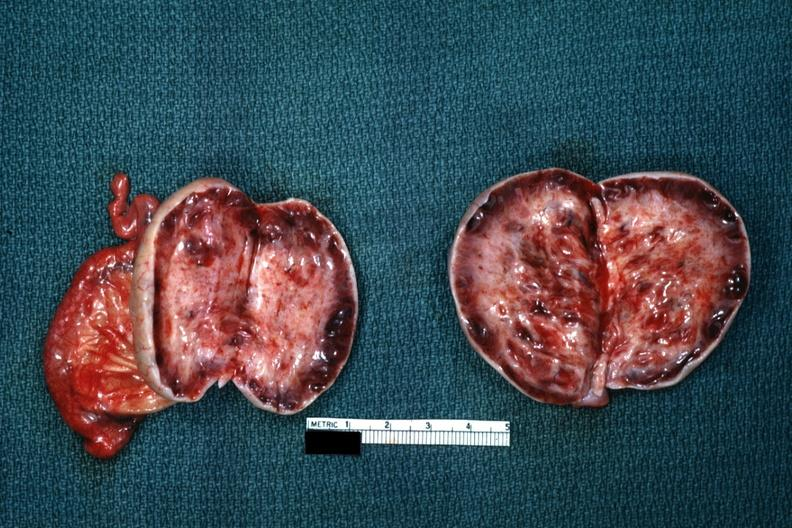does leiomyoma show thick capsule with some cysts?
Answer the question using a single word or phrase. No 